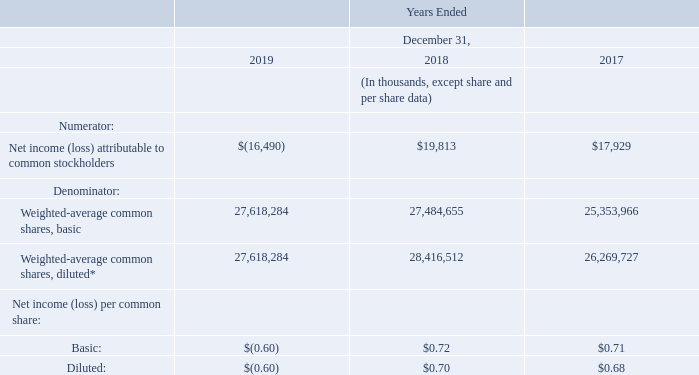NET INCOME (LOSS) PER COMMON SHARE
Basic net income (loss) per common share is based upon the weighted-average number of common shares outstanding. Diluted net income (loss) per common share is based on the weighted-average number of common shares outstanding and potentially dilutive common shares outstanding and computed as follows:
* For the twelve months ended December 31, 2018, the diluted earnings per common share included the weighted average effect of 215,196 unvested Restricted Stock Units and 716,661 stock options that are potentially dilutive to earnings per share since the exercise price of such securities was less than the average market price during the period. For the twelve months ended December 31, 2017, the diluted earnings per common share included 438,712 unvested Restricted Stock Units and the weighted average effect of 477,048 stock options that are potentially dilutive to earnings per share since the exercise price of such securities was less than the average market price during the period.
What is the respective number of unvested Restricted Stock Units and stock options included in the diluted earnings per common share for the twelve months ended December 31, 2018? 215,196, 716,661. What is the respective number of unvested Restricted Stock Units and stock options included in the diluted earnings per common share for the twelve months ended December 31, 2017? 438,712, 477,048. What is the respective number of weighted-average common shares, basic in 2019 and 2018 respectively? 27,618,284, 27,484,655. What is the number of unvested Restricted Stock Units as a percentage of the total Weighted-average common shares, diluted in 2018?
Answer scale should be: percent. 215,196/28,416,512 
Answer: 0.76. What is the number of unvested Restricted Stock Units as a percentage of the total Weighted-average common shares, diluted in 2017?
Answer scale should be: percent. 438,712 /26,269,727 
Answer: 1.67. What is the number of potentially dilutive stock options as a percentage of the total Weighted-average common shares, diluted in 2018?
Answer scale should be: percent. 716,661/28,416,512 
Answer: 2.52. 